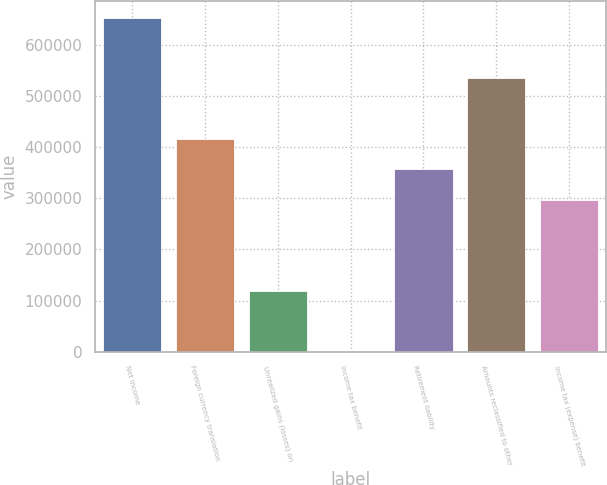Convert chart to OTSL. <chart><loc_0><loc_0><loc_500><loc_500><bar_chart><fcel>Net income<fcel>Foreign currency translation<fcel>Unrealized gains (losses) on<fcel>Income tax benefit<fcel>Retirement liability<fcel>Amounts reclassified to other<fcel>Income tax (expense) benefit<nl><fcel>653129<fcel>415789<fcel>119113<fcel>443<fcel>356454<fcel>534459<fcel>297118<nl></chart> 